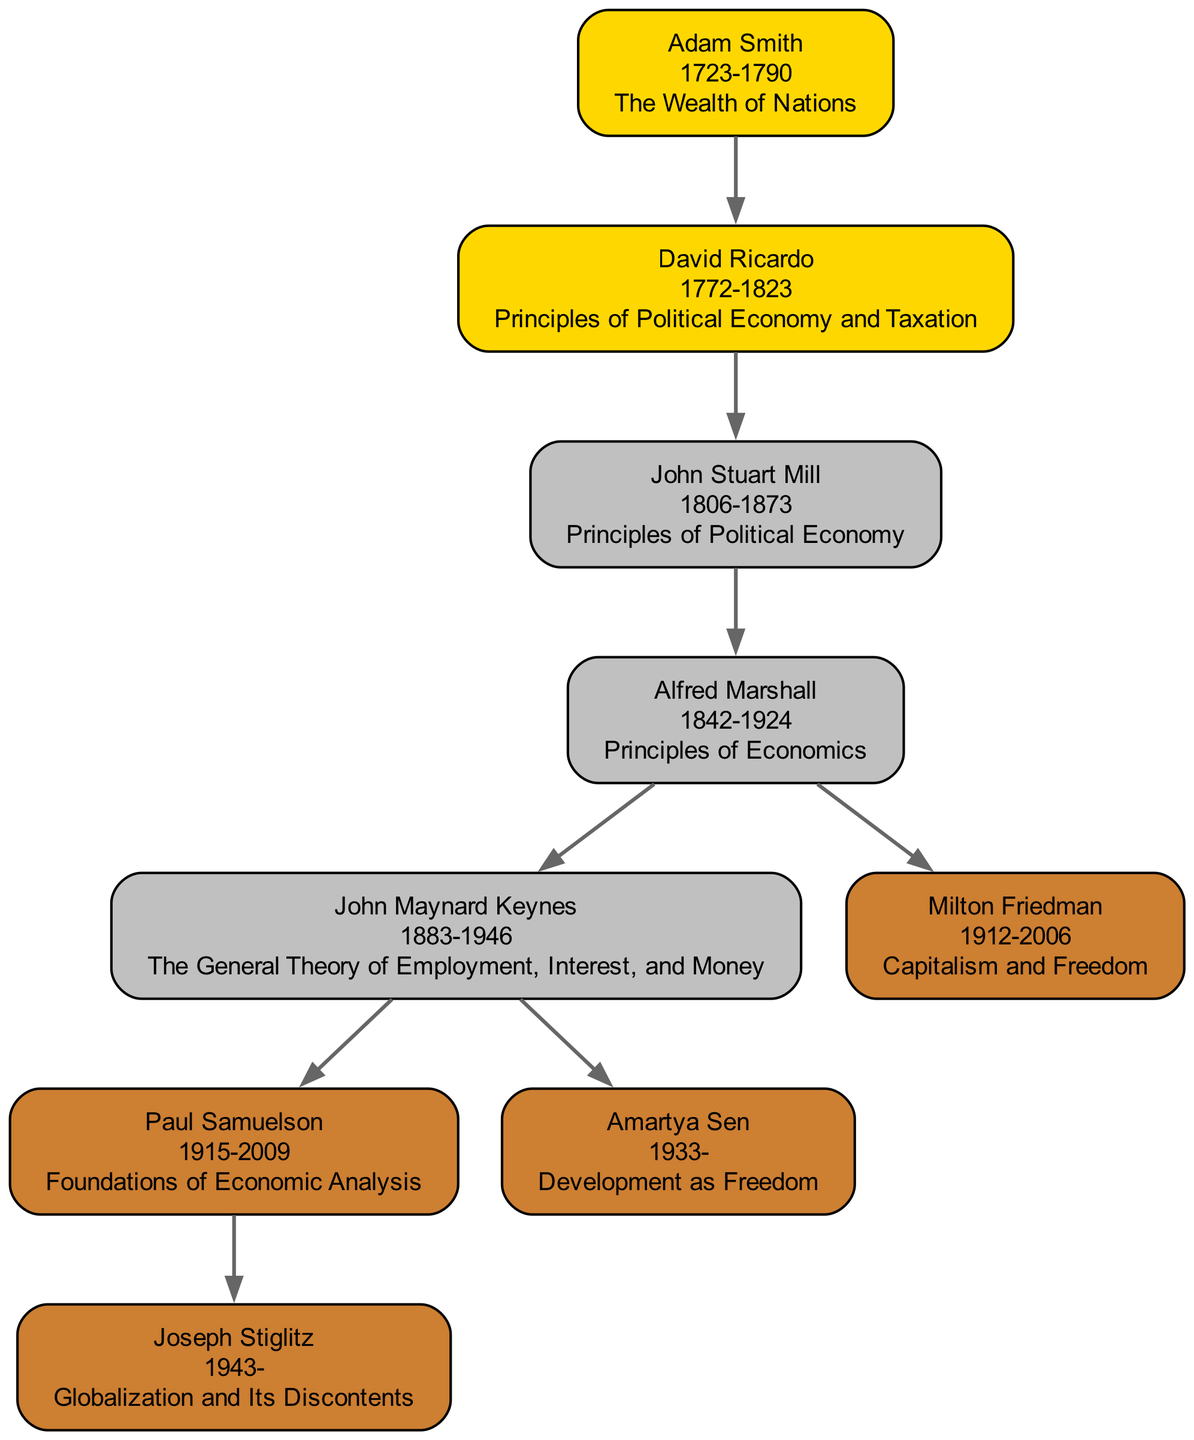What is the key work of John Stuart Mill? The diagram includes John Stuart Mill, and his key work is explicitly mentioned under his node. It is "Principles of Political Economy".
Answer: Principles of Political Economy Who mentored Joseph Stiglitz? Joseph Stiglitz's node in the diagram indicates that he was mentored by Paul Samuelson, which is connected by a directed edge from Samuelson to Stiglitz.
Answer: Paul Samuelson How many economists are born in the 20th century? The diagram can be analyzed for birth years. The economists who fall under the 20th century (born from 1900 to 1999) are John Maynard Keynes, Paul Samuelson, Milton Friedman, and Joseph Stiglitz. Therefore, there are four economists.
Answer: 4 What key work is associated with Adam Smith? Adam Smith’s node in the diagram provides the title of his key work, which is "The Wealth of Nations". This is clearly stated in his label.
Answer: The Wealth of Nations Which economist is directly mentored by Alfred Marshall? The diagram shows two economists mentored by Alfred Marshall: John Maynard Keynes and Milton Friedman. This can be determined by looking at the directed edges from Alfred Marshall's node to both Keynes and Friedman.
Answer: John Maynard Keynes, Milton Friedman How many total edges are present in the diagram? To find the total number of edges, count the connections from each economist to their mentor in the diagram. There are a total of seven directed edges representing mentorship relationships.
Answer: 7 What is the birth year of David Ricardo? The diagram provides the birth year associated with David Ricardo, which is represented in his node. It states that he was born in 1772.
Answer: 1772 Who is the earliest-born economist represented in the diagram? By examining the birth years of all economists in the diagram, Adam Smith, born in 1723, is determined to be the earliest-born.
Answer: Adam Smith What is the last year of life listed for any economist in the diagram? The year of death for each economist is listed in their respective nodes. The last year mentioned is 2009 for Paul Samuelson.
Answer: 2009 